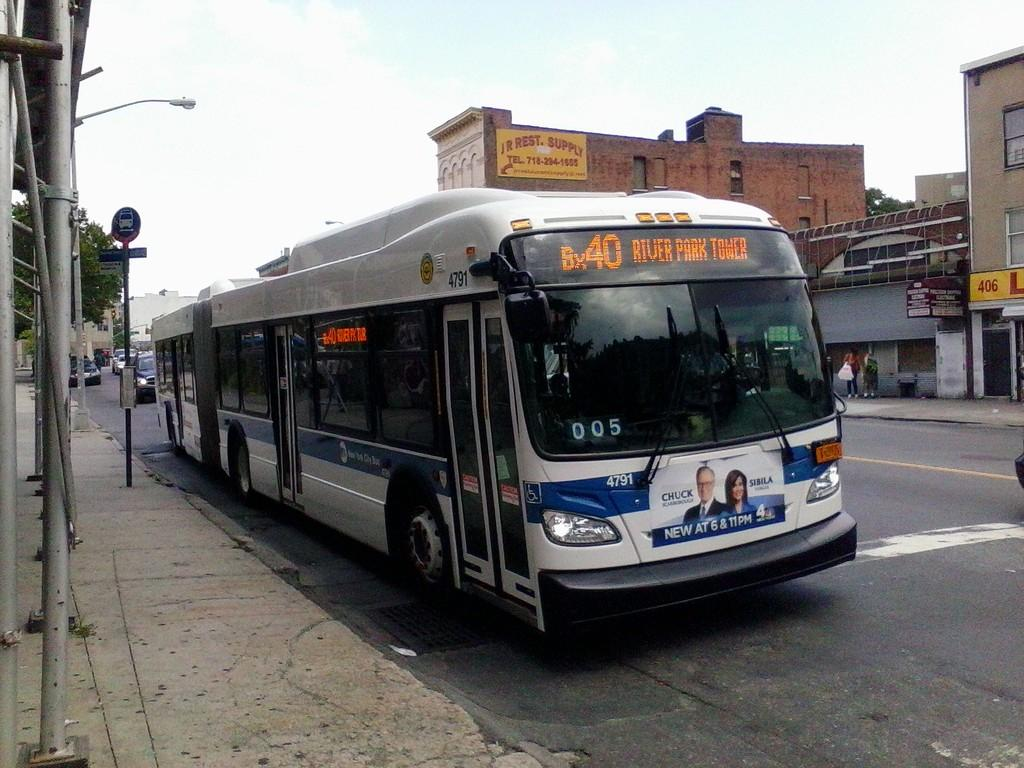What can be seen on the road in the image? There are vehicles on the road in the image. What type of structures are present in the image? There are buildings in the image. What type of vegetation is visible in the image? There is a tree in the image. What is visible above the structures and vehicles in the image? The sky is visible in the image. How many houses can be seen in the image? There is no mention of houses in the provided facts, so we cannot determine the number of houses in the image. What type of box is visible in the image? There is no box present in the image. 